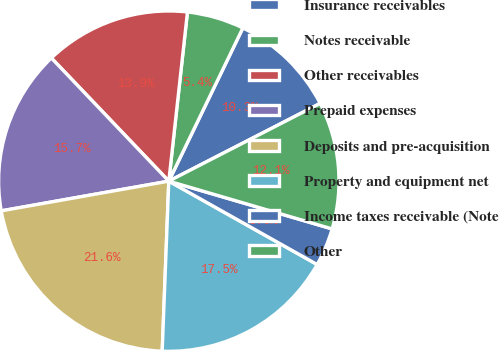Convert chart. <chart><loc_0><loc_0><loc_500><loc_500><pie_chart><fcel>Insurance receivables<fcel>Notes receivable<fcel>Other receivables<fcel>Prepaid expenses<fcel>Deposits and pre-acquisition<fcel>Property and equipment net<fcel>Income taxes receivable (Note<fcel>Other<nl><fcel>10.28%<fcel>5.42%<fcel>13.87%<fcel>15.67%<fcel>21.59%<fcel>17.47%<fcel>3.62%<fcel>12.08%<nl></chart> 